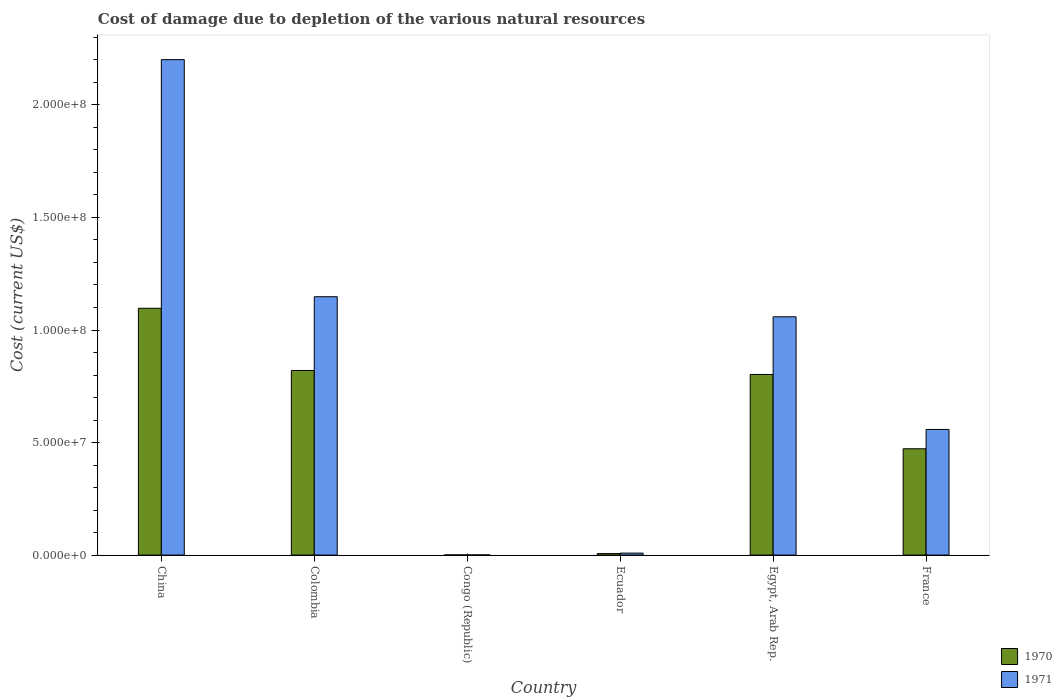Are the number of bars per tick equal to the number of legend labels?
Keep it short and to the point. Yes. How many bars are there on the 3rd tick from the right?
Give a very brief answer. 2. What is the label of the 2nd group of bars from the left?
Offer a terse response. Colombia. What is the cost of damage caused due to the depletion of various natural resources in 1970 in France?
Offer a very short reply. 4.72e+07. Across all countries, what is the maximum cost of damage caused due to the depletion of various natural resources in 1970?
Make the answer very short. 1.10e+08. Across all countries, what is the minimum cost of damage caused due to the depletion of various natural resources in 1970?
Your answer should be compact. 6.34e+04. In which country was the cost of damage caused due to the depletion of various natural resources in 1971 minimum?
Make the answer very short. Congo (Republic). What is the total cost of damage caused due to the depletion of various natural resources in 1970 in the graph?
Your answer should be compact. 3.20e+08. What is the difference between the cost of damage caused due to the depletion of various natural resources in 1970 in China and that in Ecuador?
Give a very brief answer. 1.09e+08. What is the difference between the cost of damage caused due to the depletion of various natural resources in 1971 in China and the cost of damage caused due to the depletion of various natural resources in 1970 in Egypt, Arab Rep.?
Make the answer very short. 1.40e+08. What is the average cost of damage caused due to the depletion of various natural resources in 1970 per country?
Ensure brevity in your answer.  5.33e+07. What is the difference between the cost of damage caused due to the depletion of various natural resources of/in 1970 and cost of damage caused due to the depletion of various natural resources of/in 1971 in France?
Give a very brief answer. -8.59e+06. What is the ratio of the cost of damage caused due to the depletion of various natural resources in 1971 in Congo (Republic) to that in Egypt, Arab Rep.?
Your answer should be very brief. 0. Is the cost of damage caused due to the depletion of various natural resources in 1971 in Congo (Republic) less than that in France?
Make the answer very short. Yes. What is the difference between the highest and the second highest cost of damage caused due to the depletion of various natural resources in 1971?
Your answer should be very brief. 8.92e+06. What is the difference between the highest and the lowest cost of damage caused due to the depletion of various natural resources in 1971?
Provide a succinct answer. 2.20e+08. Is the sum of the cost of damage caused due to the depletion of various natural resources in 1970 in Colombia and Ecuador greater than the maximum cost of damage caused due to the depletion of various natural resources in 1971 across all countries?
Make the answer very short. No. What does the 1st bar from the right in Colombia represents?
Make the answer very short. 1971. Are all the bars in the graph horizontal?
Keep it short and to the point. No. How many countries are there in the graph?
Give a very brief answer. 6. What is the difference between two consecutive major ticks on the Y-axis?
Keep it short and to the point. 5.00e+07. Does the graph contain grids?
Provide a succinct answer. No. Where does the legend appear in the graph?
Your answer should be compact. Bottom right. How many legend labels are there?
Keep it short and to the point. 2. How are the legend labels stacked?
Provide a succinct answer. Vertical. What is the title of the graph?
Keep it short and to the point. Cost of damage due to depletion of the various natural resources. What is the label or title of the Y-axis?
Offer a very short reply. Cost (current US$). What is the Cost (current US$) in 1970 in China?
Keep it short and to the point. 1.10e+08. What is the Cost (current US$) in 1971 in China?
Your answer should be compact. 2.20e+08. What is the Cost (current US$) in 1970 in Colombia?
Offer a very short reply. 8.20e+07. What is the Cost (current US$) of 1971 in Colombia?
Give a very brief answer. 1.15e+08. What is the Cost (current US$) in 1970 in Congo (Republic)?
Provide a succinct answer. 6.34e+04. What is the Cost (current US$) in 1971 in Congo (Republic)?
Your response must be concise. 7.34e+04. What is the Cost (current US$) of 1970 in Ecuador?
Offer a terse response. 6.65e+05. What is the Cost (current US$) in 1971 in Ecuador?
Offer a very short reply. 8.71e+05. What is the Cost (current US$) of 1970 in Egypt, Arab Rep.?
Your answer should be compact. 8.02e+07. What is the Cost (current US$) in 1971 in Egypt, Arab Rep.?
Provide a succinct answer. 1.06e+08. What is the Cost (current US$) of 1970 in France?
Offer a terse response. 4.72e+07. What is the Cost (current US$) in 1971 in France?
Make the answer very short. 5.58e+07. Across all countries, what is the maximum Cost (current US$) in 1970?
Your answer should be very brief. 1.10e+08. Across all countries, what is the maximum Cost (current US$) of 1971?
Ensure brevity in your answer.  2.20e+08. Across all countries, what is the minimum Cost (current US$) of 1970?
Give a very brief answer. 6.34e+04. Across all countries, what is the minimum Cost (current US$) in 1971?
Keep it short and to the point. 7.34e+04. What is the total Cost (current US$) of 1970 in the graph?
Keep it short and to the point. 3.20e+08. What is the total Cost (current US$) in 1971 in the graph?
Offer a terse response. 4.98e+08. What is the difference between the Cost (current US$) in 1970 in China and that in Colombia?
Your answer should be very brief. 2.76e+07. What is the difference between the Cost (current US$) of 1971 in China and that in Colombia?
Make the answer very short. 1.05e+08. What is the difference between the Cost (current US$) in 1970 in China and that in Congo (Republic)?
Your response must be concise. 1.10e+08. What is the difference between the Cost (current US$) in 1971 in China and that in Congo (Republic)?
Your answer should be very brief. 2.20e+08. What is the difference between the Cost (current US$) in 1970 in China and that in Ecuador?
Give a very brief answer. 1.09e+08. What is the difference between the Cost (current US$) of 1971 in China and that in Ecuador?
Offer a terse response. 2.19e+08. What is the difference between the Cost (current US$) of 1970 in China and that in Egypt, Arab Rep.?
Provide a short and direct response. 2.94e+07. What is the difference between the Cost (current US$) in 1971 in China and that in Egypt, Arab Rep.?
Your response must be concise. 1.14e+08. What is the difference between the Cost (current US$) in 1970 in China and that in France?
Your answer should be compact. 6.24e+07. What is the difference between the Cost (current US$) of 1971 in China and that in France?
Your answer should be very brief. 1.64e+08. What is the difference between the Cost (current US$) in 1970 in Colombia and that in Congo (Republic)?
Provide a succinct answer. 8.20e+07. What is the difference between the Cost (current US$) in 1971 in Colombia and that in Congo (Republic)?
Ensure brevity in your answer.  1.15e+08. What is the difference between the Cost (current US$) of 1970 in Colombia and that in Ecuador?
Provide a short and direct response. 8.14e+07. What is the difference between the Cost (current US$) of 1971 in Colombia and that in Ecuador?
Make the answer very short. 1.14e+08. What is the difference between the Cost (current US$) of 1970 in Colombia and that in Egypt, Arab Rep.?
Your answer should be very brief. 1.77e+06. What is the difference between the Cost (current US$) of 1971 in Colombia and that in Egypt, Arab Rep.?
Provide a succinct answer. 8.92e+06. What is the difference between the Cost (current US$) in 1970 in Colombia and that in France?
Your response must be concise. 3.48e+07. What is the difference between the Cost (current US$) of 1971 in Colombia and that in France?
Your answer should be very brief. 5.90e+07. What is the difference between the Cost (current US$) of 1970 in Congo (Republic) and that in Ecuador?
Provide a short and direct response. -6.01e+05. What is the difference between the Cost (current US$) of 1971 in Congo (Republic) and that in Ecuador?
Your response must be concise. -7.98e+05. What is the difference between the Cost (current US$) in 1970 in Congo (Republic) and that in Egypt, Arab Rep.?
Make the answer very short. -8.02e+07. What is the difference between the Cost (current US$) in 1971 in Congo (Republic) and that in Egypt, Arab Rep.?
Give a very brief answer. -1.06e+08. What is the difference between the Cost (current US$) in 1970 in Congo (Republic) and that in France?
Your answer should be very brief. -4.72e+07. What is the difference between the Cost (current US$) in 1971 in Congo (Republic) and that in France?
Provide a short and direct response. -5.57e+07. What is the difference between the Cost (current US$) in 1970 in Ecuador and that in Egypt, Arab Rep.?
Provide a short and direct response. -7.96e+07. What is the difference between the Cost (current US$) in 1971 in Ecuador and that in Egypt, Arab Rep.?
Offer a very short reply. -1.05e+08. What is the difference between the Cost (current US$) of 1970 in Ecuador and that in France?
Offer a very short reply. -4.66e+07. What is the difference between the Cost (current US$) in 1971 in Ecuador and that in France?
Make the answer very short. -5.49e+07. What is the difference between the Cost (current US$) in 1970 in Egypt, Arab Rep. and that in France?
Your answer should be compact. 3.30e+07. What is the difference between the Cost (current US$) in 1971 in Egypt, Arab Rep. and that in France?
Your response must be concise. 5.01e+07. What is the difference between the Cost (current US$) in 1970 in China and the Cost (current US$) in 1971 in Colombia?
Offer a terse response. -5.13e+06. What is the difference between the Cost (current US$) of 1970 in China and the Cost (current US$) of 1971 in Congo (Republic)?
Your answer should be very brief. 1.10e+08. What is the difference between the Cost (current US$) of 1970 in China and the Cost (current US$) of 1971 in Ecuador?
Make the answer very short. 1.09e+08. What is the difference between the Cost (current US$) in 1970 in China and the Cost (current US$) in 1971 in Egypt, Arab Rep.?
Provide a succinct answer. 3.78e+06. What is the difference between the Cost (current US$) of 1970 in China and the Cost (current US$) of 1971 in France?
Keep it short and to the point. 5.38e+07. What is the difference between the Cost (current US$) in 1970 in Colombia and the Cost (current US$) in 1971 in Congo (Republic)?
Offer a very short reply. 8.19e+07. What is the difference between the Cost (current US$) of 1970 in Colombia and the Cost (current US$) of 1971 in Ecuador?
Provide a succinct answer. 8.11e+07. What is the difference between the Cost (current US$) in 1970 in Colombia and the Cost (current US$) in 1971 in Egypt, Arab Rep.?
Your response must be concise. -2.39e+07. What is the difference between the Cost (current US$) in 1970 in Colombia and the Cost (current US$) in 1971 in France?
Your answer should be very brief. 2.62e+07. What is the difference between the Cost (current US$) in 1970 in Congo (Republic) and the Cost (current US$) in 1971 in Ecuador?
Keep it short and to the point. -8.08e+05. What is the difference between the Cost (current US$) in 1970 in Congo (Republic) and the Cost (current US$) in 1971 in Egypt, Arab Rep.?
Keep it short and to the point. -1.06e+08. What is the difference between the Cost (current US$) of 1970 in Congo (Republic) and the Cost (current US$) of 1971 in France?
Offer a very short reply. -5.58e+07. What is the difference between the Cost (current US$) in 1970 in Ecuador and the Cost (current US$) in 1971 in Egypt, Arab Rep.?
Offer a terse response. -1.05e+08. What is the difference between the Cost (current US$) in 1970 in Ecuador and the Cost (current US$) in 1971 in France?
Make the answer very short. -5.52e+07. What is the difference between the Cost (current US$) of 1970 in Egypt, Arab Rep. and the Cost (current US$) of 1971 in France?
Give a very brief answer. 2.44e+07. What is the average Cost (current US$) of 1970 per country?
Give a very brief answer. 5.33e+07. What is the average Cost (current US$) of 1971 per country?
Provide a short and direct response. 8.29e+07. What is the difference between the Cost (current US$) of 1970 and Cost (current US$) of 1971 in China?
Your answer should be compact. -1.10e+08. What is the difference between the Cost (current US$) of 1970 and Cost (current US$) of 1971 in Colombia?
Give a very brief answer. -3.28e+07. What is the difference between the Cost (current US$) of 1970 and Cost (current US$) of 1971 in Congo (Republic)?
Your answer should be very brief. -1.00e+04. What is the difference between the Cost (current US$) in 1970 and Cost (current US$) in 1971 in Ecuador?
Give a very brief answer. -2.07e+05. What is the difference between the Cost (current US$) of 1970 and Cost (current US$) of 1971 in Egypt, Arab Rep.?
Provide a succinct answer. -2.56e+07. What is the difference between the Cost (current US$) of 1970 and Cost (current US$) of 1971 in France?
Offer a very short reply. -8.59e+06. What is the ratio of the Cost (current US$) of 1970 in China to that in Colombia?
Provide a succinct answer. 1.34. What is the ratio of the Cost (current US$) of 1971 in China to that in Colombia?
Keep it short and to the point. 1.92. What is the ratio of the Cost (current US$) in 1970 in China to that in Congo (Republic)?
Ensure brevity in your answer.  1728.88. What is the ratio of the Cost (current US$) in 1971 in China to that in Congo (Republic)?
Ensure brevity in your answer.  2997.27. What is the ratio of the Cost (current US$) in 1970 in China to that in Ecuador?
Offer a terse response. 164.99. What is the ratio of the Cost (current US$) in 1971 in China to that in Ecuador?
Give a very brief answer. 252.64. What is the ratio of the Cost (current US$) in 1970 in China to that in Egypt, Arab Rep.?
Your answer should be very brief. 1.37. What is the ratio of the Cost (current US$) of 1971 in China to that in Egypt, Arab Rep.?
Provide a short and direct response. 2.08. What is the ratio of the Cost (current US$) of 1970 in China to that in France?
Offer a terse response. 2.32. What is the ratio of the Cost (current US$) in 1971 in China to that in France?
Ensure brevity in your answer.  3.94. What is the ratio of the Cost (current US$) in 1970 in Colombia to that in Congo (Republic)?
Your answer should be very brief. 1293.18. What is the ratio of the Cost (current US$) of 1971 in Colombia to that in Congo (Republic)?
Make the answer very short. 1562.98. What is the ratio of the Cost (current US$) of 1970 in Colombia to that in Ecuador?
Make the answer very short. 123.41. What is the ratio of the Cost (current US$) in 1971 in Colombia to that in Ecuador?
Offer a terse response. 131.75. What is the ratio of the Cost (current US$) of 1970 in Colombia to that in Egypt, Arab Rep.?
Ensure brevity in your answer.  1.02. What is the ratio of the Cost (current US$) of 1971 in Colombia to that in Egypt, Arab Rep.?
Provide a succinct answer. 1.08. What is the ratio of the Cost (current US$) of 1970 in Colombia to that in France?
Ensure brevity in your answer.  1.74. What is the ratio of the Cost (current US$) of 1971 in Colombia to that in France?
Give a very brief answer. 2.06. What is the ratio of the Cost (current US$) of 1970 in Congo (Republic) to that in Ecuador?
Offer a terse response. 0.1. What is the ratio of the Cost (current US$) in 1971 in Congo (Republic) to that in Ecuador?
Provide a succinct answer. 0.08. What is the ratio of the Cost (current US$) in 1970 in Congo (Republic) to that in Egypt, Arab Rep.?
Ensure brevity in your answer.  0. What is the ratio of the Cost (current US$) of 1971 in Congo (Republic) to that in Egypt, Arab Rep.?
Offer a very short reply. 0. What is the ratio of the Cost (current US$) in 1970 in Congo (Republic) to that in France?
Give a very brief answer. 0. What is the ratio of the Cost (current US$) of 1971 in Congo (Republic) to that in France?
Provide a succinct answer. 0. What is the ratio of the Cost (current US$) in 1970 in Ecuador to that in Egypt, Arab Rep.?
Your answer should be very brief. 0.01. What is the ratio of the Cost (current US$) in 1971 in Ecuador to that in Egypt, Arab Rep.?
Keep it short and to the point. 0.01. What is the ratio of the Cost (current US$) of 1970 in Ecuador to that in France?
Offer a very short reply. 0.01. What is the ratio of the Cost (current US$) of 1971 in Ecuador to that in France?
Offer a terse response. 0.02. What is the ratio of the Cost (current US$) in 1970 in Egypt, Arab Rep. to that in France?
Offer a terse response. 1.7. What is the ratio of the Cost (current US$) in 1971 in Egypt, Arab Rep. to that in France?
Ensure brevity in your answer.  1.9. What is the difference between the highest and the second highest Cost (current US$) in 1970?
Offer a terse response. 2.76e+07. What is the difference between the highest and the second highest Cost (current US$) of 1971?
Your answer should be compact. 1.05e+08. What is the difference between the highest and the lowest Cost (current US$) of 1970?
Offer a very short reply. 1.10e+08. What is the difference between the highest and the lowest Cost (current US$) of 1971?
Offer a very short reply. 2.20e+08. 